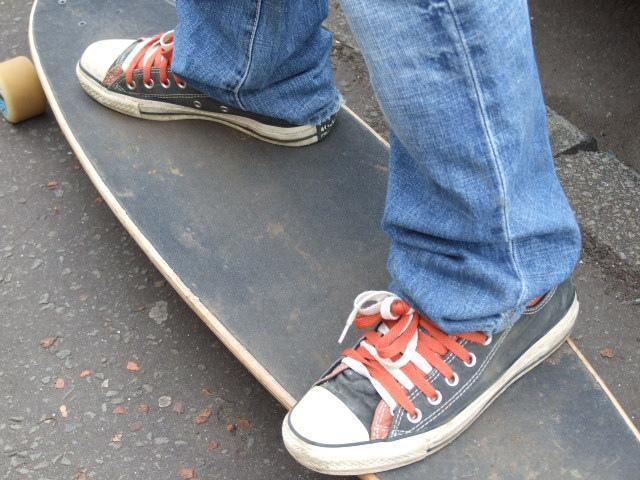How many feet are in focus?
Give a very brief answer. 2. How many red chairs are there?
Give a very brief answer. 0. 